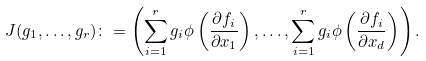<formula> <loc_0><loc_0><loc_500><loc_500>J ( g _ { 1 } , \dots , g _ { r } ) \colon = \left ( \sum _ { i = 1 } ^ { r } g _ { i } \phi \left ( \frac { \partial f _ { i } } { \partial x _ { 1 } } \right ) , \dots , \sum _ { i = 1 } ^ { r } g _ { i } \phi \left ( \frac { \partial f _ { i } } { \partial x _ { d } } \right ) \right ) .</formula> 